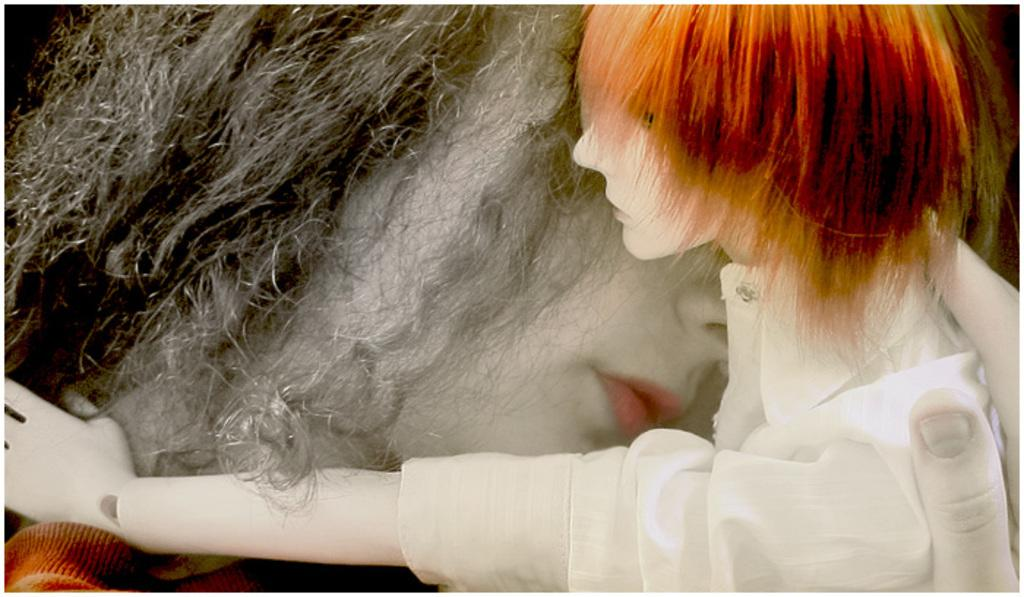How many dolls are present in the image? There are two dolls in the image. What is one doll doing with the other doll? One doll is holding the other doll. What type of snake can be seen slithering in the image? There is no snake present in the image. What meal is being prepared in the image? There is no meal preparation depicted in the image. 